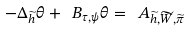Convert formula to latex. <formula><loc_0><loc_0><loc_500><loc_500>- \Delta _ { \widetilde { h } } \theta + \ B _ { \tau , \psi } \theta = \ A _ { \widetilde { h } , \widetilde { W } , \widetilde { \pi } }</formula> 